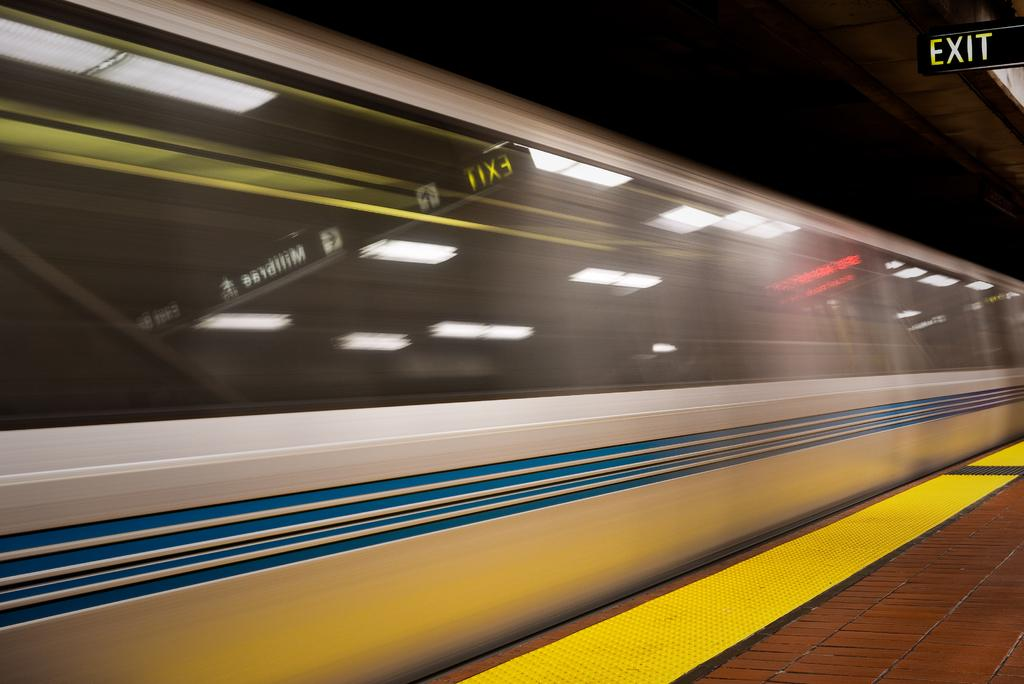What is the main subject in the middle of the image? There is a train in the middle of the image. What is the surface on which the train is situated? There is a floor at the bottom of the image. Where can an exit or route information be found in the image? There is an exit board in the top right corner of the image. What type of company is responsible for the acoustics in the train? There is no information about the company or the acoustics in the image. 